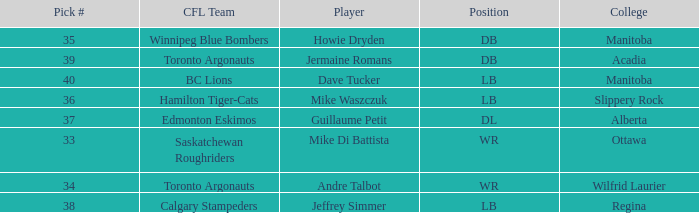What Player has a College that is alberta? Guillaume Petit. 